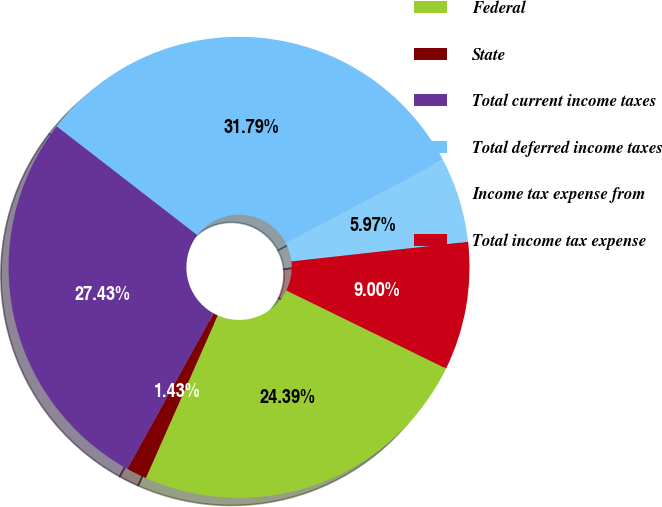Convert chart to OTSL. <chart><loc_0><loc_0><loc_500><loc_500><pie_chart><fcel>Federal<fcel>State<fcel>Total current income taxes<fcel>Total deferred income taxes<fcel>Income tax expense from<fcel>Total income tax expense<nl><fcel>24.39%<fcel>1.43%<fcel>27.43%<fcel>31.79%<fcel>5.97%<fcel>9.0%<nl></chart> 